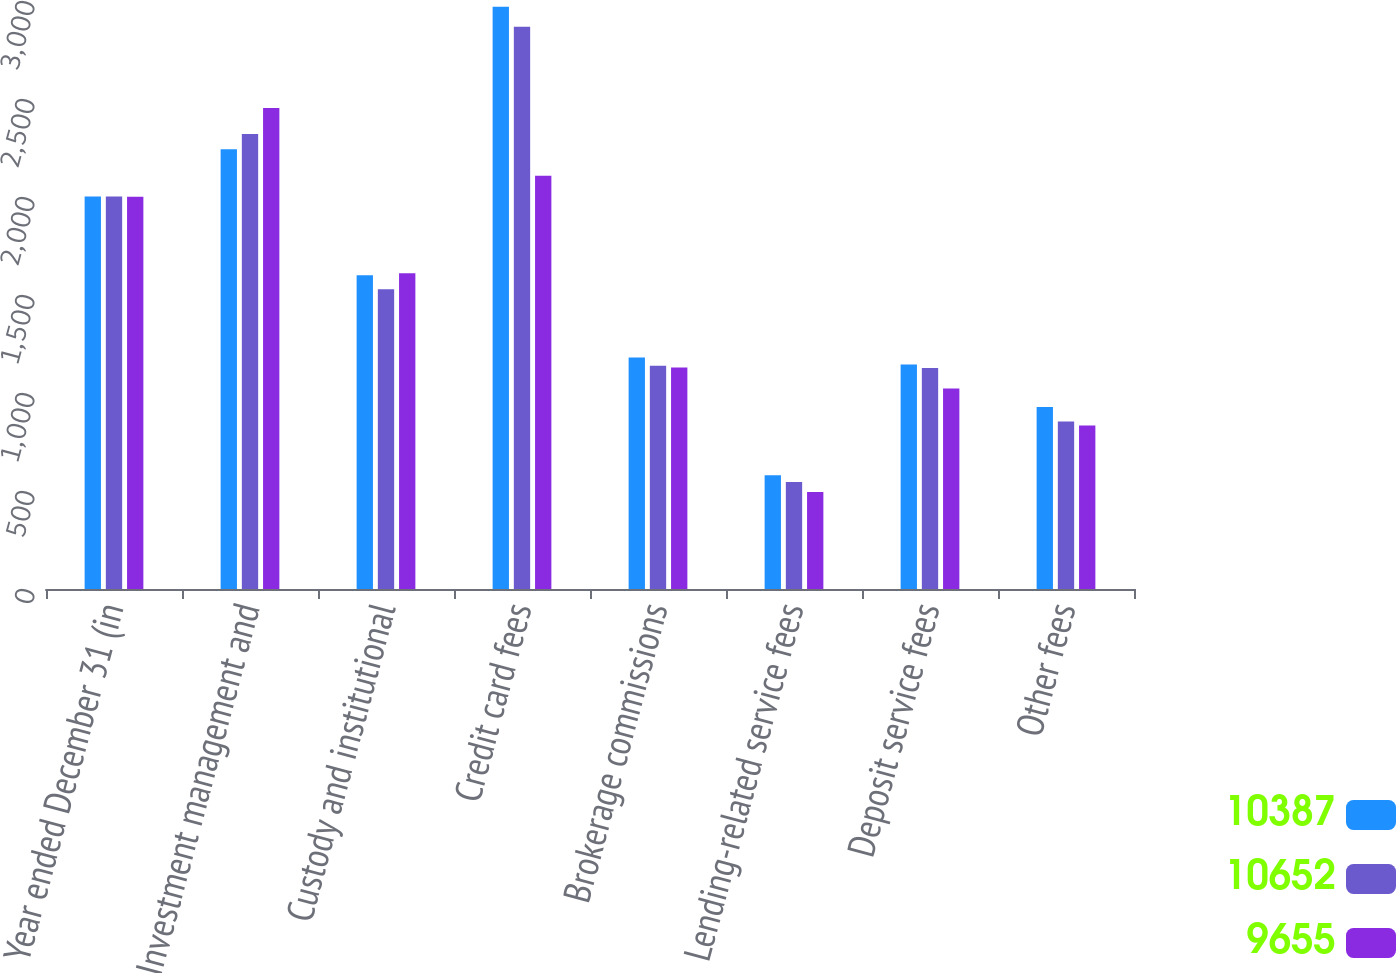Convert chart. <chart><loc_0><loc_0><loc_500><loc_500><stacked_bar_chart><ecel><fcel>Year ended December 31 (in<fcel>Investment management and<fcel>Custody and institutional<fcel>Credit card fees<fcel>Brokerage commissions<fcel>Lending-related service fees<fcel>Deposit service fees<fcel>Other fees<nl><fcel>10387<fcel>2003<fcel>2244<fcel>1601<fcel>2971<fcel>1181<fcel>580<fcel>1146<fcel>929<nl><fcel>10652<fcel>2002<fcel>2322<fcel>1529<fcel>2869<fcel>1139<fcel>546<fcel>1128<fcel>854<nl><fcel>9655<fcel>2001<fcel>2454<fcel>1611<fcel>2108<fcel>1130<fcel>495<fcel>1023<fcel>834<nl></chart> 